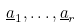Convert formula to latex. <formula><loc_0><loc_0><loc_500><loc_500>\underline { a } _ { 1 } , \dots , \underline { a } _ { r }</formula> 